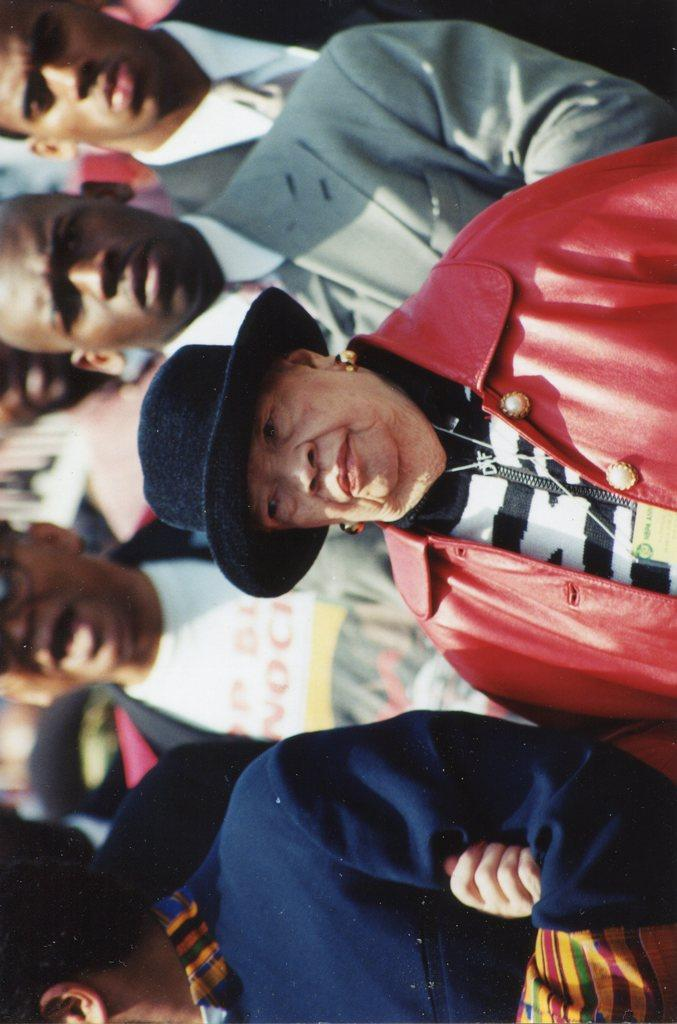How many people are in the image? There are people in the image, but the exact number is not specified. Where are the people located in the image? The people are standing in the middle of the image. What are the people doing in the image? The people are watching something. What type of girl is causing a shock in the image? There is no girl or shock present in the image. 